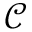<formula> <loc_0><loc_0><loc_500><loc_500>\mathcal { C }</formula> 